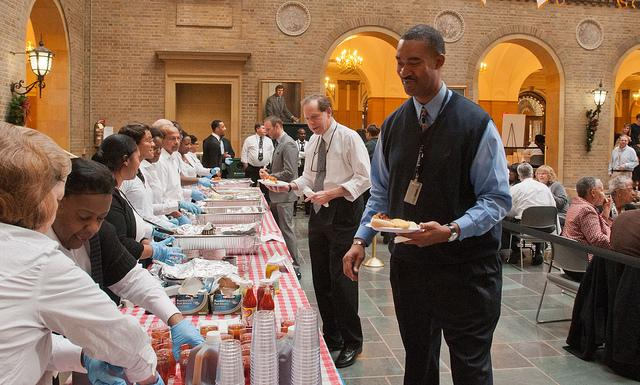Why should they wear gloves?

Choices:
A) cold weather
B) identifying themselves
C) hygiene
D) fashion hygiene 